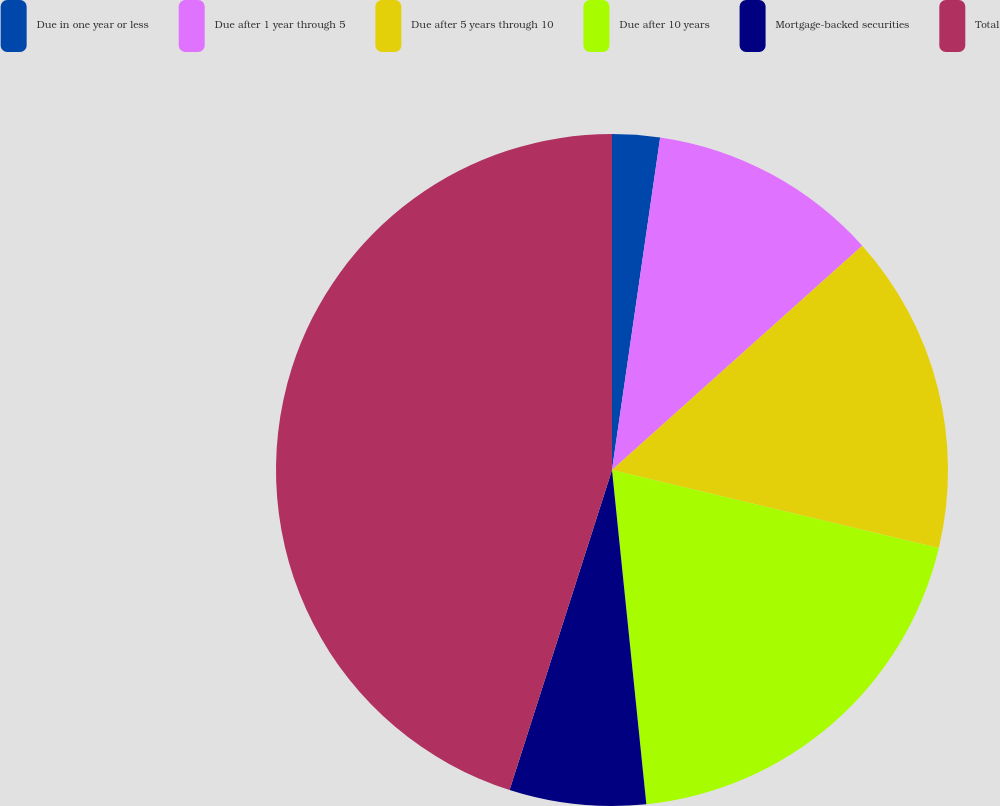Convert chart to OTSL. <chart><loc_0><loc_0><loc_500><loc_500><pie_chart><fcel>Due in one year or less<fcel>Due after 1 year through 5<fcel>Due after 5 years through 10<fcel>Due after 10 years<fcel>Mortgage-backed securities<fcel>Total<nl><fcel>2.29%<fcel>11.08%<fcel>15.36%<fcel>19.64%<fcel>6.56%<fcel>45.07%<nl></chart> 